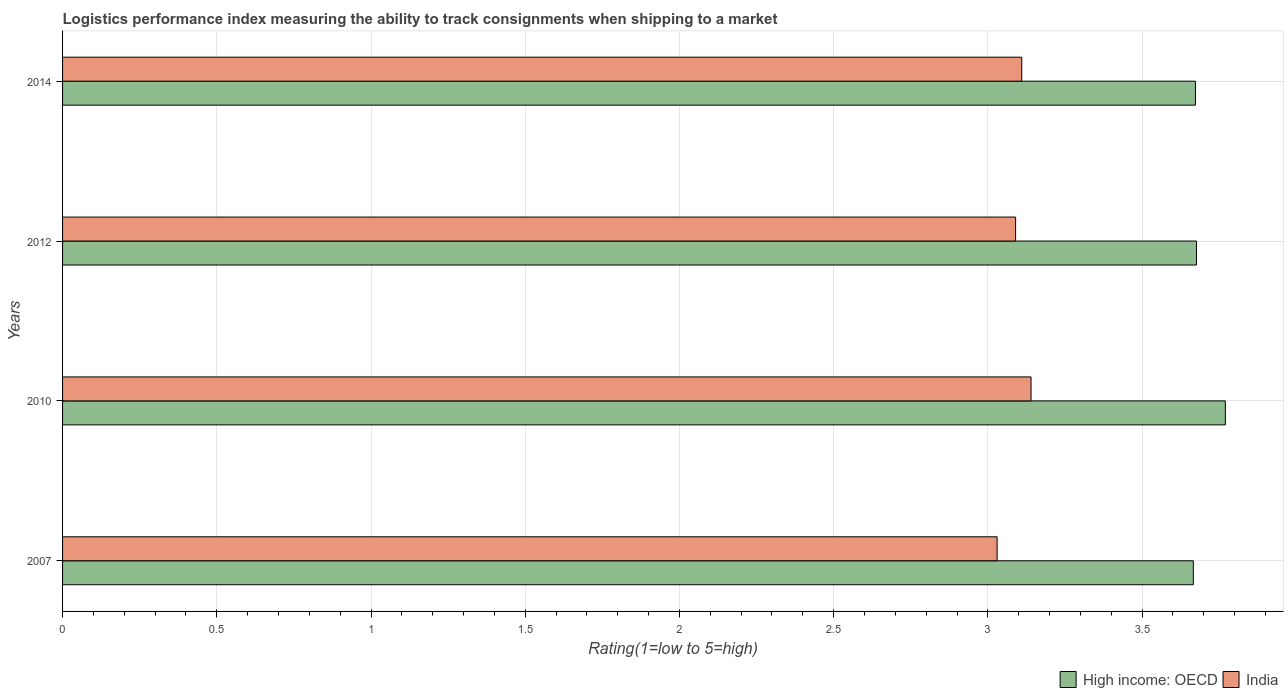How many groups of bars are there?
Provide a short and direct response. 4. Are the number of bars per tick equal to the number of legend labels?
Keep it short and to the point. Yes. How many bars are there on the 1st tick from the top?
Your answer should be compact. 2. How many bars are there on the 1st tick from the bottom?
Your response must be concise. 2. What is the label of the 4th group of bars from the top?
Offer a very short reply. 2007. What is the Logistic performance index in India in 2012?
Provide a succinct answer. 3.09. Across all years, what is the maximum Logistic performance index in India?
Offer a very short reply. 3.14. Across all years, what is the minimum Logistic performance index in High income: OECD?
Your response must be concise. 3.67. In which year was the Logistic performance index in High income: OECD minimum?
Provide a short and direct response. 2007. What is the total Logistic performance index in India in the graph?
Make the answer very short. 12.37. What is the difference between the Logistic performance index in India in 2007 and that in 2012?
Make the answer very short. -0.06. What is the difference between the Logistic performance index in High income: OECD in 2010 and the Logistic performance index in India in 2014?
Provide a short and direct response. 0.66. What is the average Logistic performance index in High income: OECD per year?
Make the answer very short. 3.7. In the year 2012, what is the difference between the Logistic performance index in High income: OECD and Logistic performance index in India?
Your answer should be compact. 0.59. What is the ratio of the Logistic performance index in High income: OECD in 2007 to that in 2010?
Your answer should be compact. 0.97. Is the difference between the Logistic performance index in High income: OECD in 2010 and 2012 greater than the difference between the Logistic performance index in India in 2010 and 2012?
Your response must be concise. Yes. What is the difference between the highest and the second highest Logistic performance index in High income: OECD?
Provide a succinct answer. 0.09. What is the difference between the highest and the lowest Logistic performance index in India?
Make the answer very short. 0.11. In how many years, is the Logistic performance index in India greater than the average Logistic performance index in India taken over all years?
Keep it short and to the point. 2. Is the sum of the Logistic performance index in High income: OECD in 2010 and 2012 greater than the maximum Logistic performance index in India across all years?
Your answer should be compact. Yes. What does the 2nd bar from the top in 2012 represents?
Make the answer very short. High income: OECD. What does the 1st bar from the bottom in 2012 represents?
Ensure brevity in your answer.  High income: OECD. Are all the bars in the graph horizontal?
Make the answer very short. Yes. What is the difference between two consecutive major ticks on the X-axis?
Your answer should be very brief. 0.5. Does the graph contain grids?
Give a very brief answer. Yes. How are the legend labels stacked?
Your answer should be compact. Horizontal. What is the title of the graph?
Your answer should be very brief. Logistics performance index measuring the ability to track consignments when shipping to a market. What is the label or title of the X-axis?
Offer a terse response. Rating(1=low to 5=high). What is the Rating(1=low to 5=high) in High income: OECD in 2007?
Provide a succinct answer. 3.67. What is the Rating(1=low to 5=high) in India in 2007?
Offer a very short reply. 3.03. What is the Rating(1=low to 5=high) in High income: OECD in 2010?
Offer a very short reply. 3.77. What is the Rating(1=low to 5=high) in India in 2010?
Provide a succinct answer. 3.14. What is the Rating(1=low to 5=high) in High income: OECD in 2012?
Your answer should be very brief. 3.68. What is the Rating(1=low to 5=high) in India in 2012?
Your answer should be compact. 3.09. What is the Rating(1=low to 5=high) in High income: OECD in 2014?
Your response must be concise. 3.67. What is the Rating(1=low to 5=high) of India in 2014?
Offer a very short reply. 3.11. Across all years, what is the maximum Rating(1=low to 5=high) in High income: OECD?
Your answer should be very brief. 3.77. Across all years, what is the maximum Rating(1=low to 5=high) of India?
Give a very brief answer. 3.14. Across all years, what is the minimum Rating(1=low to 5=high) in High income: OECD?
Provide a succinct answer. 3.67. Across all years, what is the minimum Rating(1=low to 5=high) of India?
Offer a terse response. 3.03. What is the total Rating(1=low to 5=high) in High income: OECD in the graph?
Offer a terse response. 14.79. What is the total Rating(1=low to 5=high) of India in the graph?
Your response must be concise. 12.37. What is the difference between the Rating(1=low to 5=high) in High income: OECD in 2007 and that in 2010?
Offer a terse response. -0.1. What is the difference between the Rating(1=low to 5=high) in India in 2007 and that in 2010?
Your answer should be compact. -0.11. What is the difference between the Rating(1=low to 5=high) in High income: OECD in 2007 and that in 2012?
Make the answer very short. -0.01. What is the difference between the Rating(1=low to 5=high) of India in 2007 and that in 2012?
Give a very brief answer. -0.06. What is the difference between the Rating(1=low to 5=high) in High income: OECD in 2007 and that in 2014?
Provide a short and direct response. -0.01. What is the difference between the Rating(1=low to 5=high) in India in 2007 and that in 2014?
Your answer should be compact. -0.08. What is the difference between the Rating(1=low to 5=high) of High income: OECD in 2010 and that in 2012?
Make the answer very short. 0.09. What is the difference between the Rating(1=low to 5=high) of High income: OECD in 2010 and that in 2014?
Ensure brevity in your answer.  0.1. What is the difference between the Rating(1=low to 5=high) of India in 2010 and that in 2014?
Provide a succinct answer. 0.03. What is the difference between the Rating(1=low to 5=high) of High income: OECD in 2012 and that in 2014?
Provide a succinct answer. 0. What is the difference between the Rating(1=low to 5=high) of India in 2012 and that in 2014?
Provide a short and direct response. -0.02. What is the difference between the Rating(1=low to 5=high) of High income: OECD in 2007 and the Rating(1=low to 5=high) of India in 2010?
Your answer should be very brief. 0.53. What is the difference between the Rating(1=low to 5=high) of High income: OECD in 2007 and the Rating(1=low to 5=high) of India in 2012?
Offer a terse response. 0.58. What is the difference between the Rating(1=low to 5=high) of High income: OECD in 2007 and the Rating(1=low to 5=high) of India in 2014?
Provide a succinct answer. 0.56. What is the difference between the Rating(1=low to 5=high) in High income: OECD in 2010 and the Rating(1=low to 5=high) in India in 2012?
Give a very brief answer. 0.68. What is the difference between the Rating(1=low to 5=high) of High income: OECD in 2010 and the Rating(1=low to 5=high) of India in 2014?
Provide a succinct answer. 0.66. What is the difference between the Rating(1=low to 5=high) of High income: OECD in 2012 and the Rating(1=low to 5=high) of India in 2014?
Ensure brevity in your answer.  0.57. What is the average Rating(1=low to 5=high) of High income: OECD per year?
Keep it short and to the point. 3.7. What is the average Rating(1=low to 5=high) of India per year?
Offer a terse response. 3.09. In the year 2007, what is the difference between the Rating(1=low to 5=high) of High income: OECD and Rating(1=low to 5=high) of India?
Offer a very short reply. 0.64. In the year 2010, what is the difference between the Rating(1=low to 5=high) of High income: OECD and Rating(1=low to 5=high) of India?
Keep it short and to the point. 0.63. In the year 2012, what is the difference between the Rating(1=low to 5=high) of High income: OECD and Rating(1=low to 5=high) of India?
Offer a terse response. 0.59. In the year 2014, what is the difference between the Rating(1=low to 5=high) of High income: OECD and Rating(1=low to 5=high) of India?
Ensure brevity in your answer.  0.56. What is the ratio of the Rating(1=low to 5=high) in High income: OECD in 2007 to that in 2010?
Your answer should be very brief. 0.97. What is the ratio of the Rating(1=low to 5=high) of India in 2007 to that in 2010?
Your answer should be very brief. 0.96. What is the ratio of the Rating(1=low to 5=high) in India in 2007 to that in 2012?
Provide a short and direct response. 0.98. What is the ratio of the Rating(1=low to 5=high) of India in 2007 to that in 2014?
Your answer should be compact. 0.97. What is the ratio of the Rating(1=low to 5=high) in High income: OECD in 2010 to that in 2012?
Keep it short and to the point. 1.03. What is the ratio of the Rating(1=low to 5=high) of India in 2010 to that in 2012?
Offer a terse response. 1.02. What is the ratio of the Rating(1=low to 5=high) of High income: OECD in 2010 to that in 2014?
Ensure brevity in your answer.  1.03. What is the ratio of the Rating(1=low to 5=high) of India in 2010 to that in 2014?
Make the answer very short. 1.01. What is the ratio of the Rating(1=low to 5=high) of High income: OECD in 2012 to that in 2014?
Provide a succinct answer. 1. What is the ratio of the Rating(1=low to 5=high) of India in 2012 to that in 2014?
Ensure brevity in your answer.  0.99. What is the difference between the highest and the second highest Rating(1=low to 5=high) of High income: OECD?
Your response must be concise. 0.09. What is the difference between the highest and the second highest Rating(1=low to 5=high) in India?
Keep it short and to the point. 0.03. What is the difference between the highest and the lowest Rating(1=low to 5=high) of High income: OECD?
Provide a succinct answer. 0.1. What is the difference between the highest and the lowest Rating(1=low to 5=high) of India?
Provide a short and direct response. 0.11. 